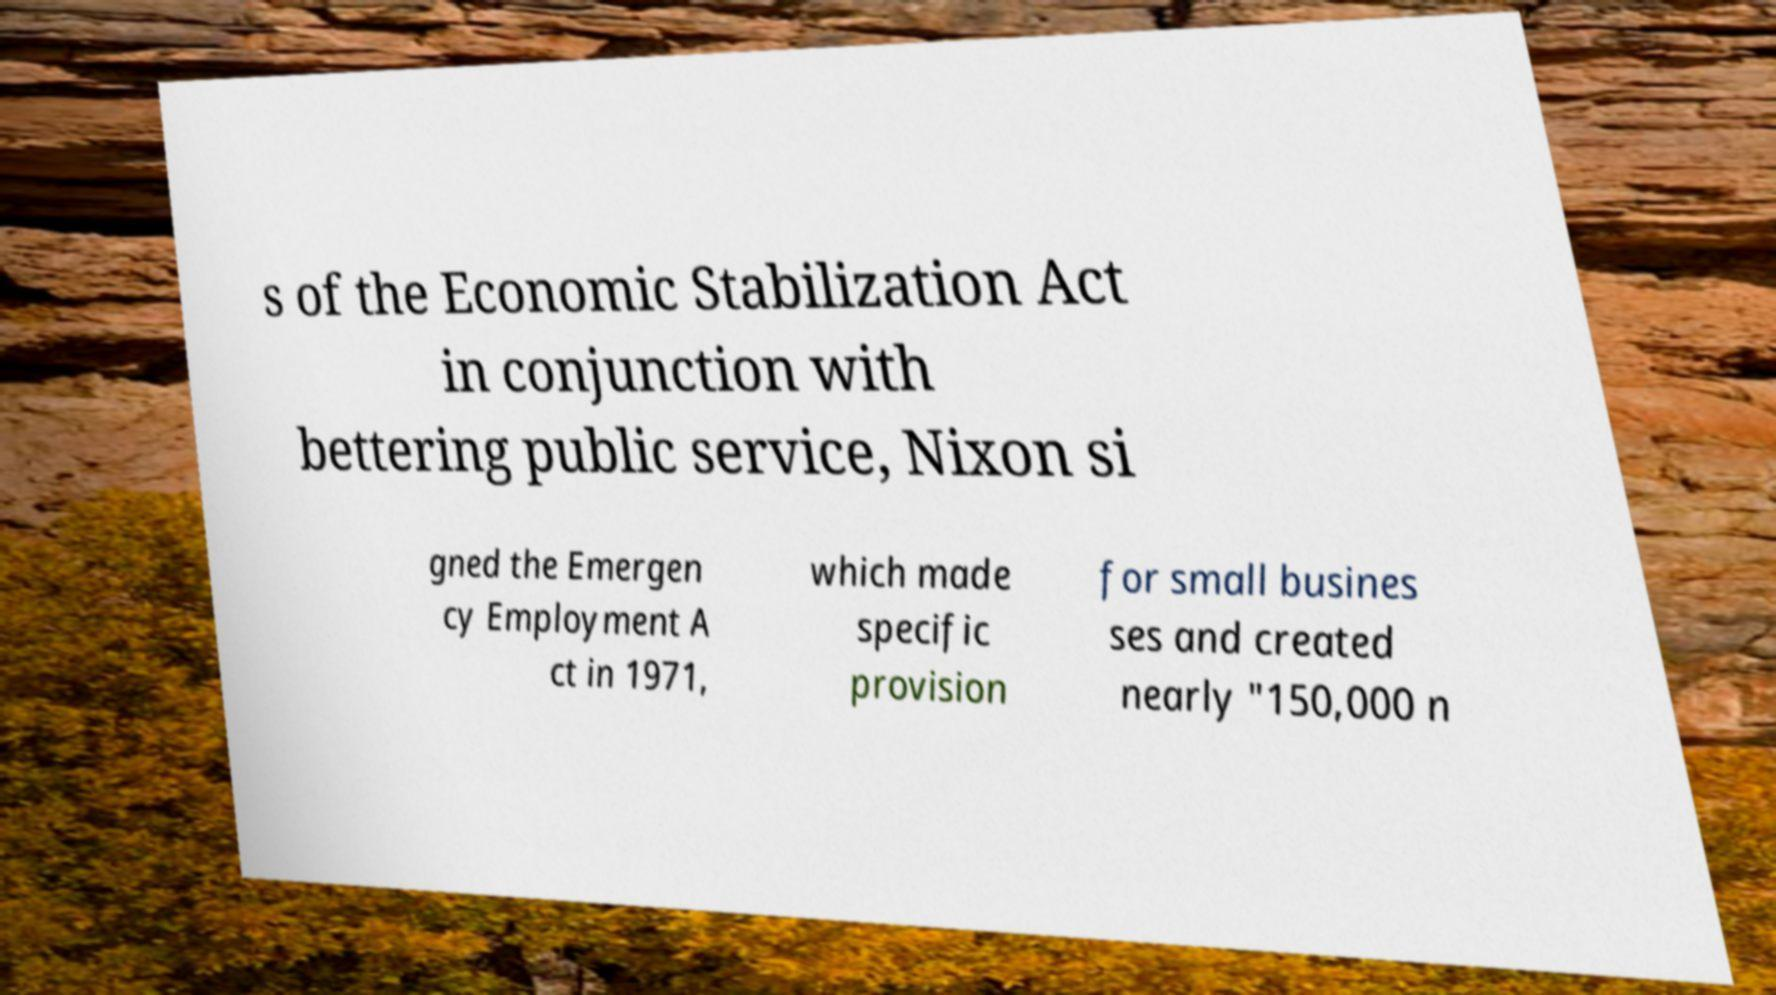Can you accurately transcribe the text from the provided image for me? s of the Economic Stabilization Act in conjunction with bettering public service, Nixon si gned the Emergen cy Employment A ct in 1971, which made specific provision for small busines ses and created nearly "150,000 n 